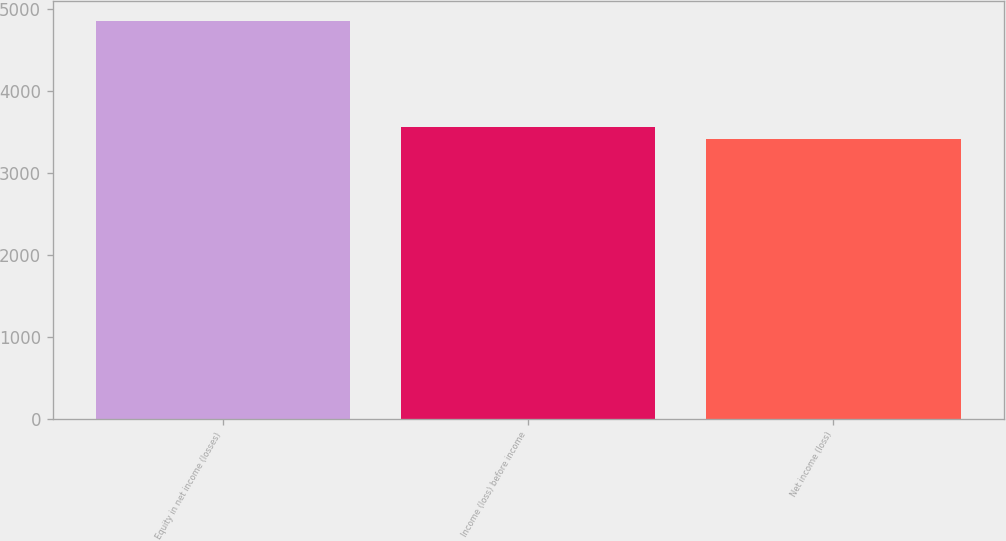Convert chart. <chart><loc_0><loc_0><loc_500><loc_500><bar_chart><fcel>Equity in net income (losses)<fcel>Income (loss) before income<fcel>Net income (loss)<nl><fcel>4852<fcel>3557.8<fcel>3414<nl></chart> 